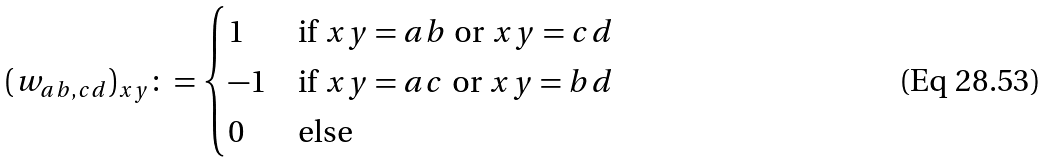Convert formula to latex. <formula><loc_0><loc_0><loc_500><loc_500>( w _ { a b , c d } ) _ { x y } \colon = \begin{cases} 1 & \text {if } x y = a b \text { or } x y = c d \\ - 1 & \text {if } x y = a c \text { or } x y = b d \\ 0 & \text {else} \end{cases}</formula> 